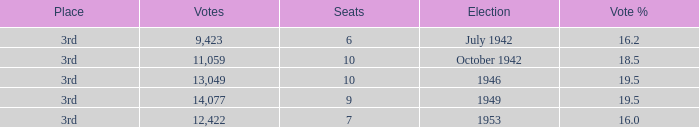Name the total number of seats for votes % more than 19.5 0.0. 